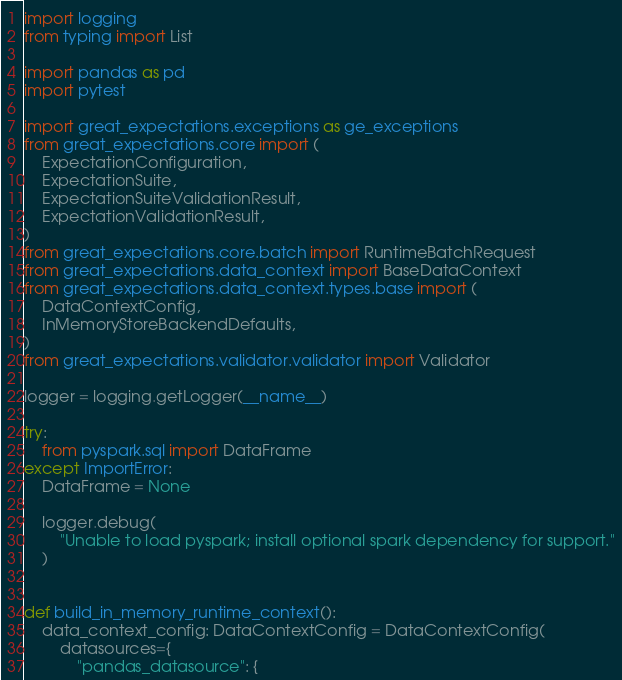Convert code to text. <code><loc_0><loc_0><loc_500><loc_500><_Python_>import logging
from typing import List

import pandas as pd
import pytest

import great_expectations.exceptions as ge_exceptions
from great_expectations.core import (
    ExpectationConfiguration,
    ExpectationSuite,
    ExpectationSuiteValidationResult,
    ExpectationValidationResult,
)
from great_expectations.core.batch import RuntimeBatchRequest
from great_expectations.data_context import BaseDataContext
from great_expectations.data_context.types.base import (
    DataContextConfig,
    InMemoryStoreBackendDefaults,
)
from great_expectations.validator.validator import Validator

logger = logging.getLogger(__name__)

try:
    from pyspark.sql import DataFrame
except ImportError:
    DataFrame = None

    logger.debug(
        "Unable to load pyspark; install optional spark dependency for support."
    )


def build_in_memory_runtime_context():
    data_context_config: DataContextConfig = DataContextConfig(
        datasources={
            "pandas_datasource": {</code> 